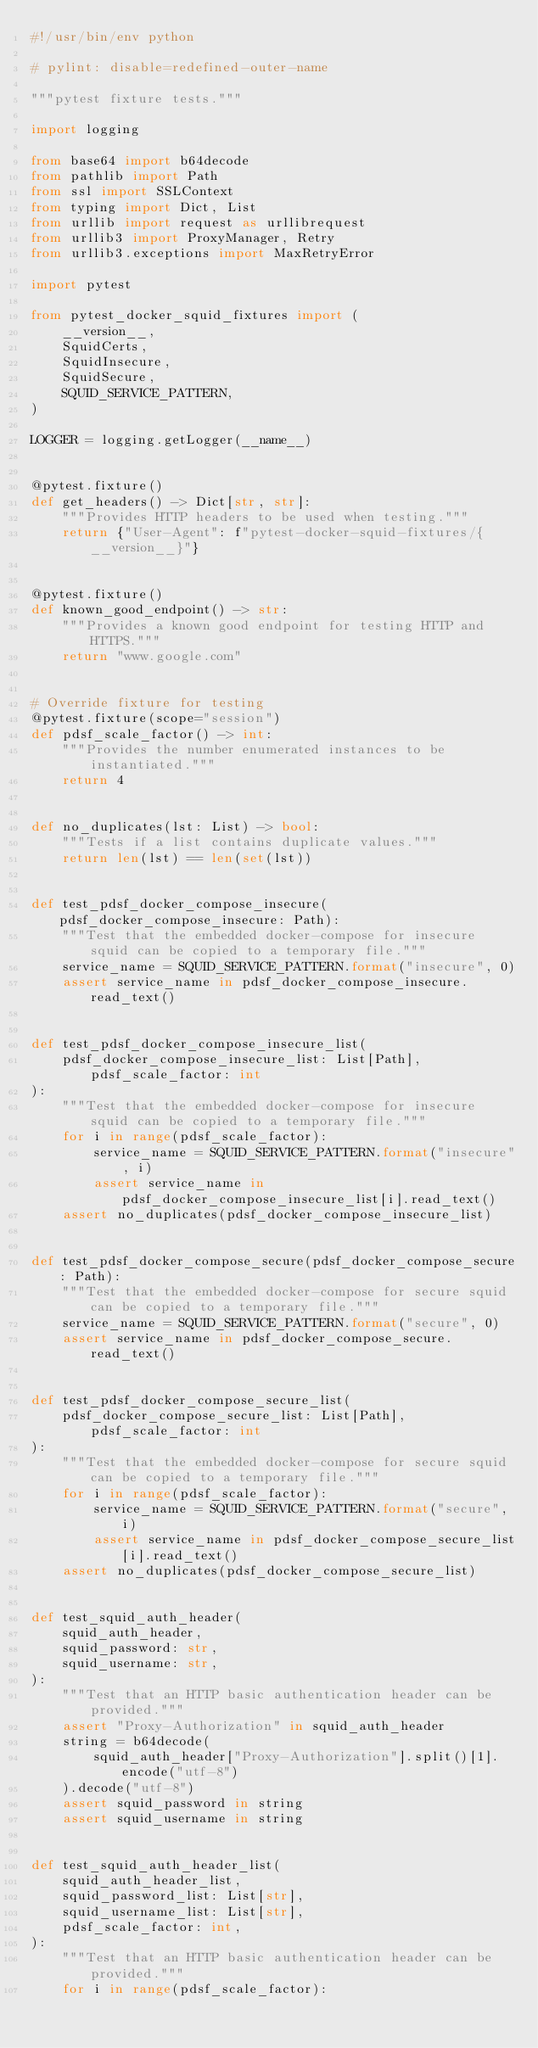Convert code to text. <code><loc_0><loc_0><loc_500><loc_500><_Python_>#!/usr/bin/env python

# pylint: disable=redefined-outer-name

"""pytest fixture tests."""

import logging

from base64 import b64decode
from pathlib import Path
from ssl import SSLContext
from typing import Dict, List
from urllib import request as urllibrequest
from urllib3 import ProxyManager, Retry
from urllib3.exceptions import MaxRetryError

import pytest

from pytest_docker_squid_fixtures import (
    __version__,
    SquidCerts,
    SquidInsecure,
    SquidSecure,
    SQUID_SERVICE_PATTERN,
)

LOGGER = logging.getLogger(__name__)


@pytest.fixture()
def get_headers() -> Dict[str, str]:
    """Provides HTTP headers to be used when testing."""
    return {"User-Agent": f"pytest-docker-squid-fixtures/{__version__}"}


@pytest.fixture()
def known_good_endpoint() -> str:
    """Provides a known good endpoint for testing HTTP and HTTPS."""
    return "www.google.com"


# Override fixture for testing
@pytest.fixture(scope="session")
def pdsf_scale_factor() -> int:
    """Provides the number enumerated instances to be instantiated."""
    return 4


def no_duplicates(lst: List) -> bool:
    """Tests if a list contains duplicate values."""
    return len(lst) == len(set(lst))


def test_pdsf_docker_compose_insecure(pdsf_docker_compose_insecure: Path):
    """Test that the embedded docker-compose for insecure squid can be copied to a temporary file."""
    service_name = SQUID_SERVICE_PATTERN.format("insecure", 0)
    assert service_name in pdsf_docker_compose_insecure.read_text()


def test_pdsf_docker_compose_insecure_list(
    pdsf_docker_compose_insecure_list: List[Path], pdsf_scale_factor: int
):
    """Test that the embedded docker-compose for insecure squid can be copied to a temporary file."""
    for i in range(pdsf_scale_factor):
        service_name = SQUID_SERVICE_PATTERN.format("insecure", i)
        assert service_name in pdsf_docker_compose_insecure_list[i].read_text()
    assert no_duplicates(pdsf_docker_compose_insecure_list)


def test_pdsf_docker_compose_secure(pdsf_docker_compose_secure: Path):
    """Test that the embedded docker-compose for secure squid can be copied to a temporary file."""
    service_name = SQUID_SERVICE_PATTERN.format("secure", 0)
    assert service_name in pdsf_docker_compose_secure.read_text()


def test_pdsf_docker_compose_secure_list(
    pdsf_docker_compose_secure_list: List[Path], pdsf_scale_factor: int
):
    """Test that the embedded docker-compose for secure squid can be copied to a temporary file."""
    for i in range(pdsf_scale_factor):
        service_name = SQUID_SERVICE_PATTERN.format("secure", i)
        assert service_name in pdsf_docker_compose_secure_list[i].read_text()
    assert no_duplicates(pdsf_docker_compose_secure_list)


def test_squid_auth_header(
    squid_auth_header,
    squid_password: str,
    squid_username: str,
):
    """Test that an HTTP basic authentication header can be provided."""
    assert "Proxy-Authorization" in squid_auth_header
    string = b64decode(
        squid_auth_header["Proxy-Authorization"].split()[1].encode("utf-8")
    ).decode("utf-8")
    assert squid_password in string
    assert squid_username in string


def test_squid_auth_header_list(
    squid_auth_header_list,
    squid_password_list: List[str],
    squid_username_list: List[str],
    pdsf_scale_factor: int,
):
    """Test that an HTTP basic authentication header can be provided."""
    for i in range(pdsf_scale_factor):</code> 